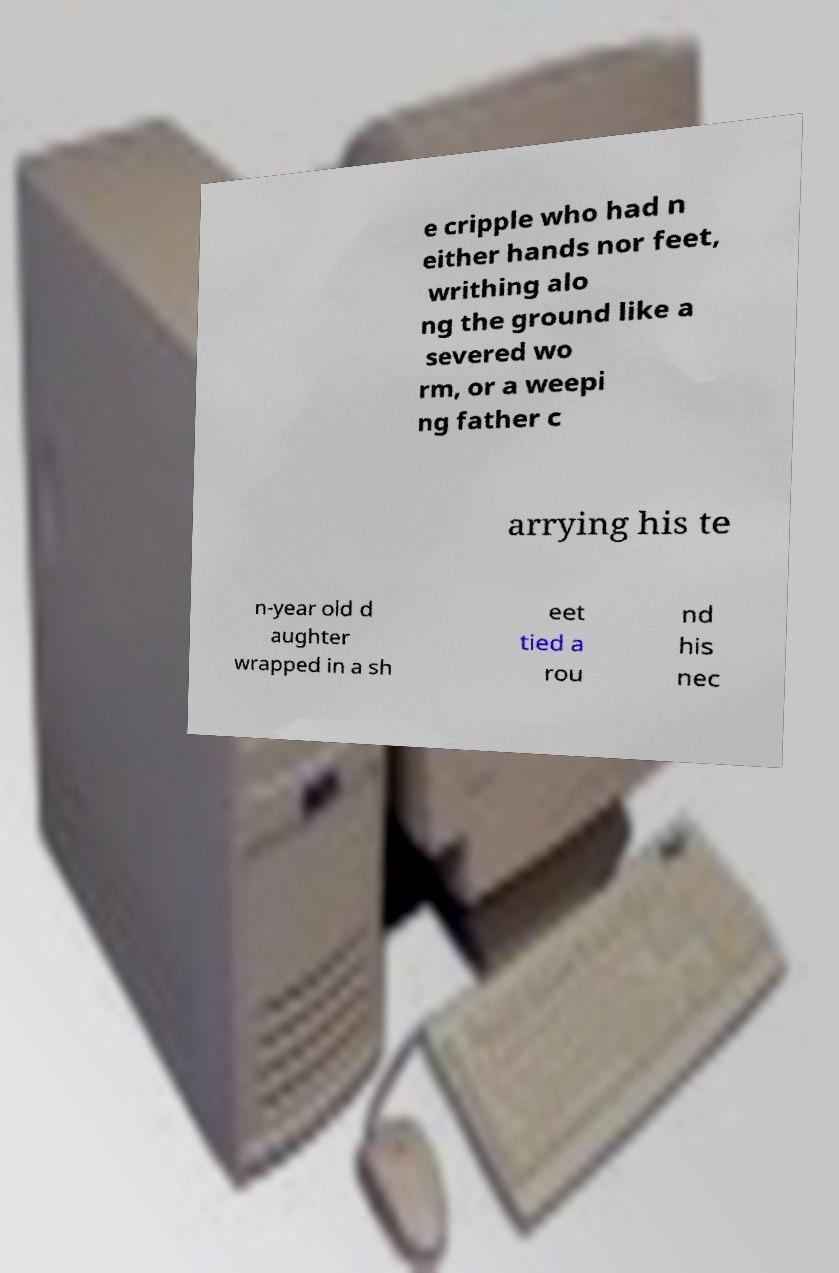There's text embedded in this image that I need extracted. Can you transcribe it verbatim? e cripple who had n either hands nor feet, writhing alo ng the ground like a severed wo rm, or a weepi ng father c arrying his te n-year old d aughter wrapped in a sh eet tied a rou nd his nec 